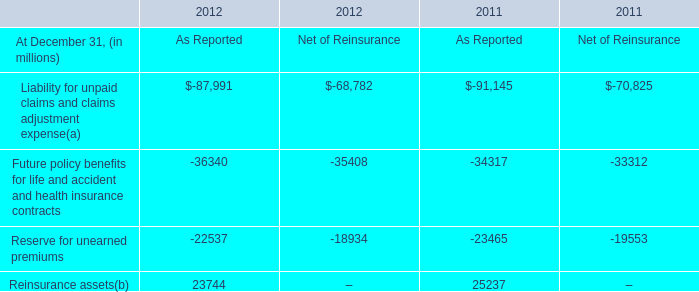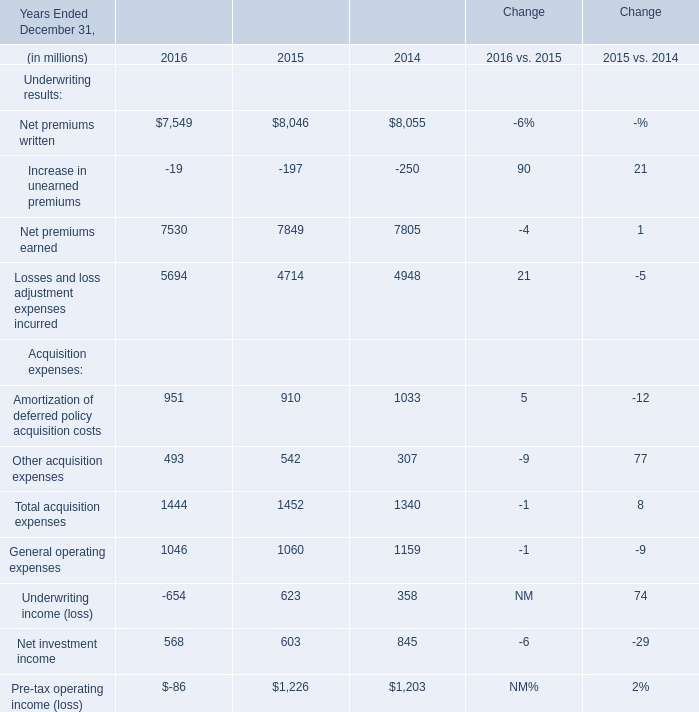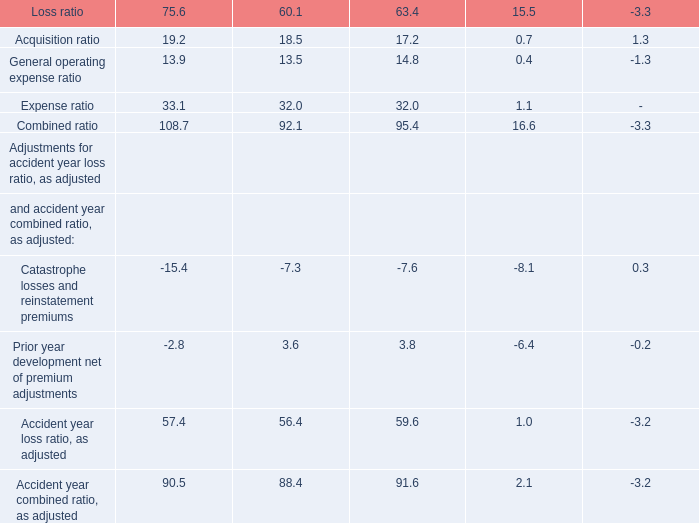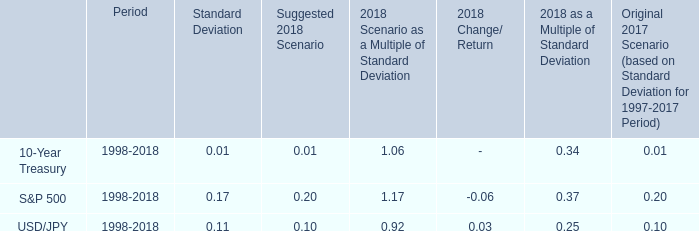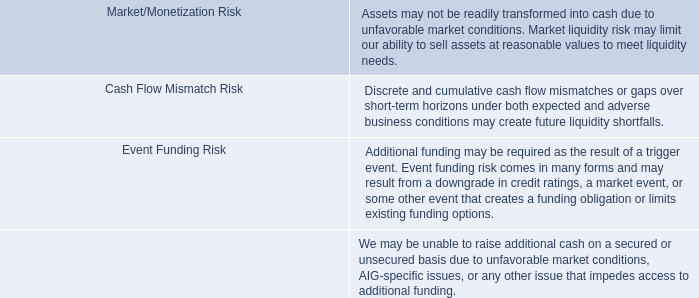What's the total amount of Net premiums earned and Pre-tax operating income (loss) in 2015? (in doller) 
Computations: (7849 + 1226)
Answer: 9075.0. 